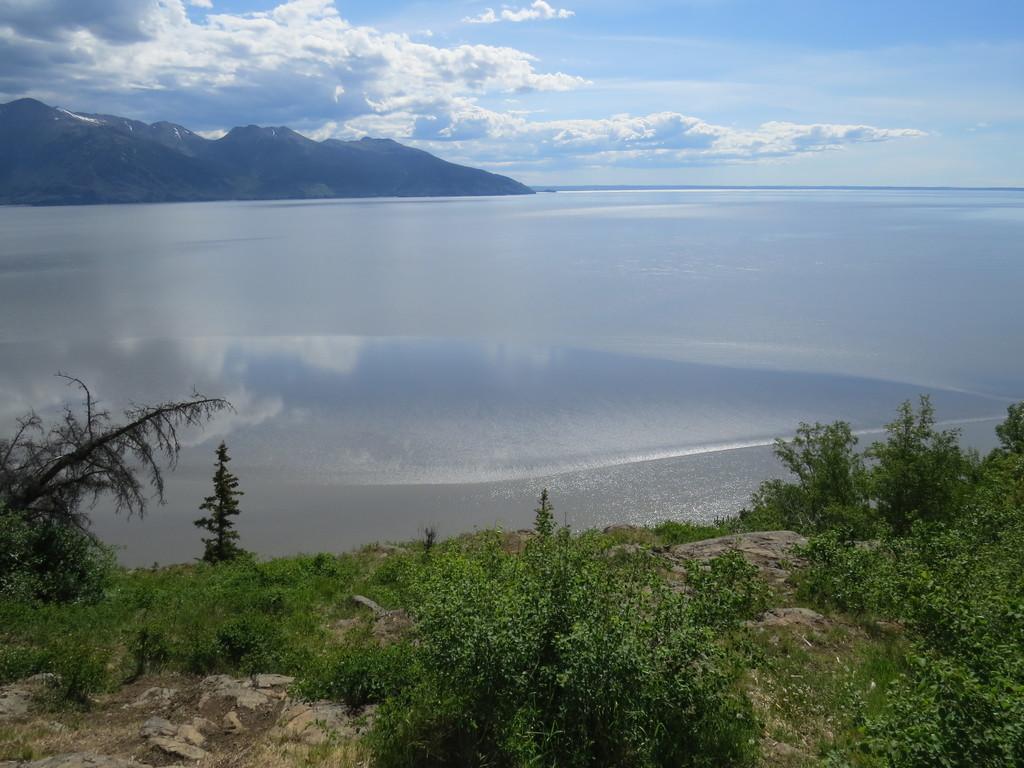Could you give a brief overview of what you see in this image? In this image, we can see some green plants, there is a sea and we can see water, there are some mountains, at the top there is a sky and we can see clouds. 